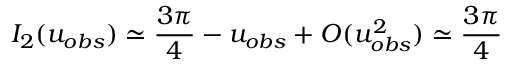Convert formula to latex. <formula><loc_0><loc_0><loc_500><loc_500>I _ { 2 } ( u _ { o b s } ) \simeq \frac { 3 \pi } { 4 } - u _ { o b s } + O ( u _ { o b s } ^ { 2 } ) \simeq \frac { 3 \pi } { 4 }</formula> 